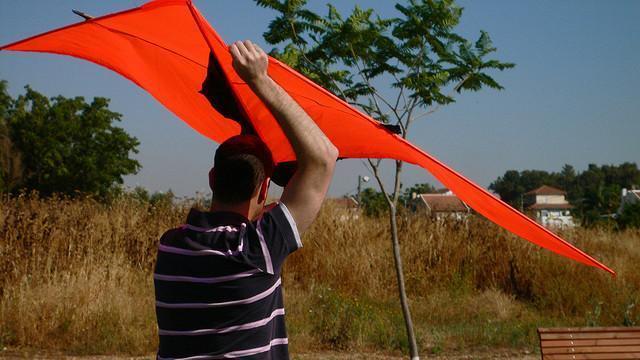How many kites can you see?
Give a very brief answer. 2. 